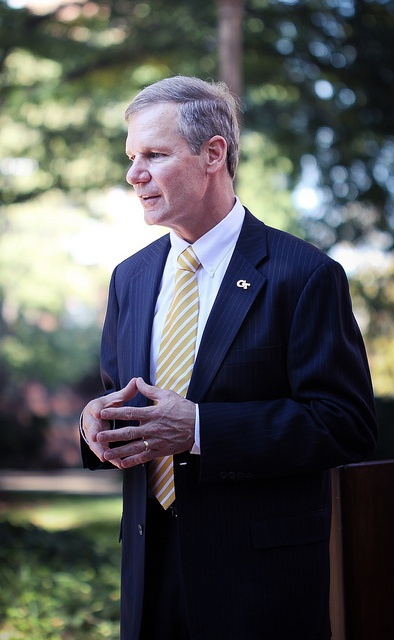Describe the objects in this image and their specific colors. I can see people in teal, black, navy, lavender, and darkgray tones and tie in teal, lavender, tan, and darkgray tones in this image. 